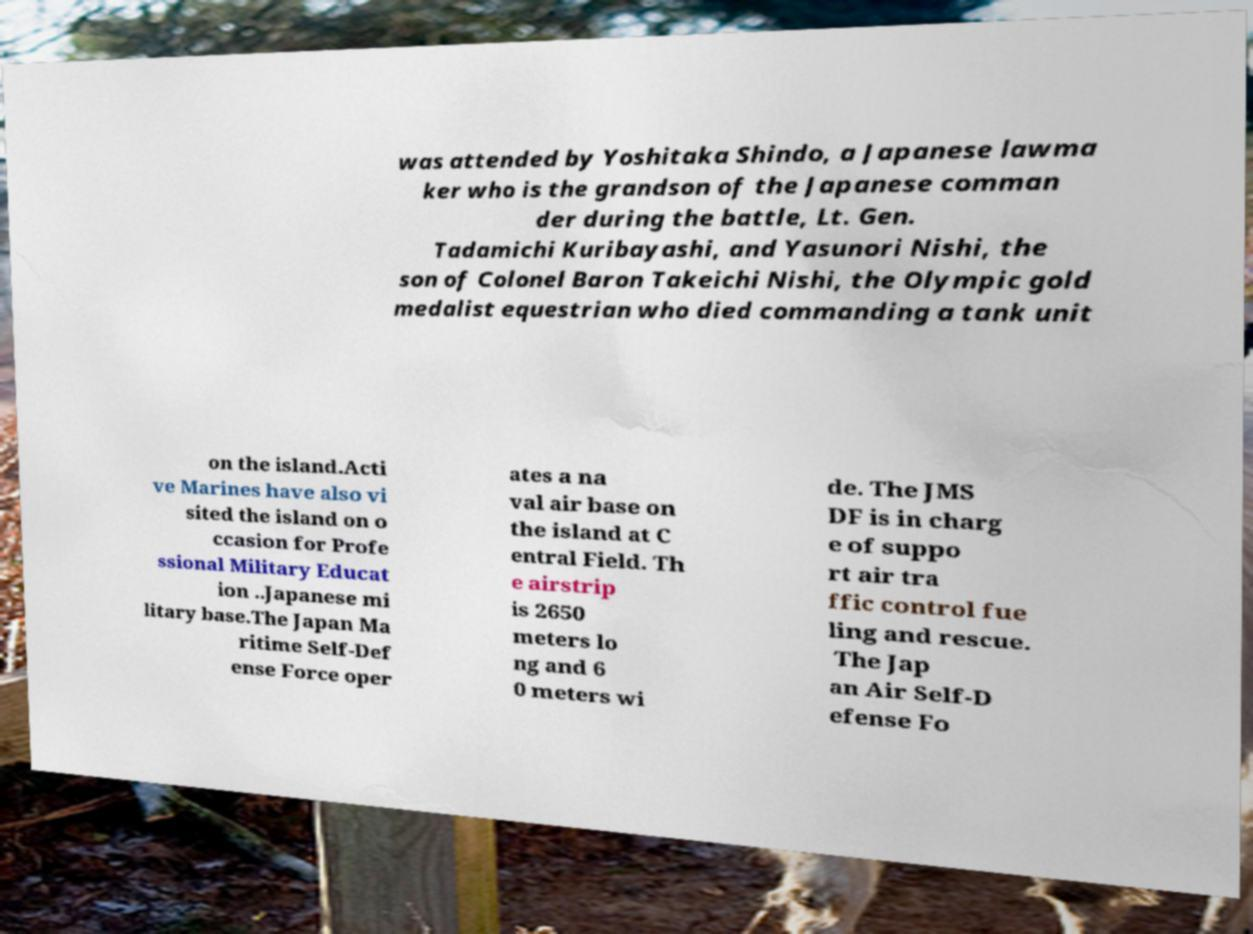Please identify and transcribe the text found in this image. was attended by Yoshitaka Shindo, a Japanese lawma ker who is the grandson of the Japanese comman der during the battle, Lt. Gen. Tadamichi Kuribayashi, and Yasunori Nishi, the son of Colonel Baron Takeichi Nishi, the Olympic gold medalist equestrian who died commanding a tank unit on the island.Acti ve Marines have also vi sited the island on o ccasion for Profe ssional Military Educat ion ..Japanese mi litary base.The Japan Ma ritime Self-Def ense Force oper ates a na val air base on the island at C entral Field. Th e airstrip is 2650 meters lo ng and 6 0 meters wi de. The JMS DF is in charg e of suppo rt air tra ffic control fue ling and rescue. The Jap an Air Self-D efense Fo 